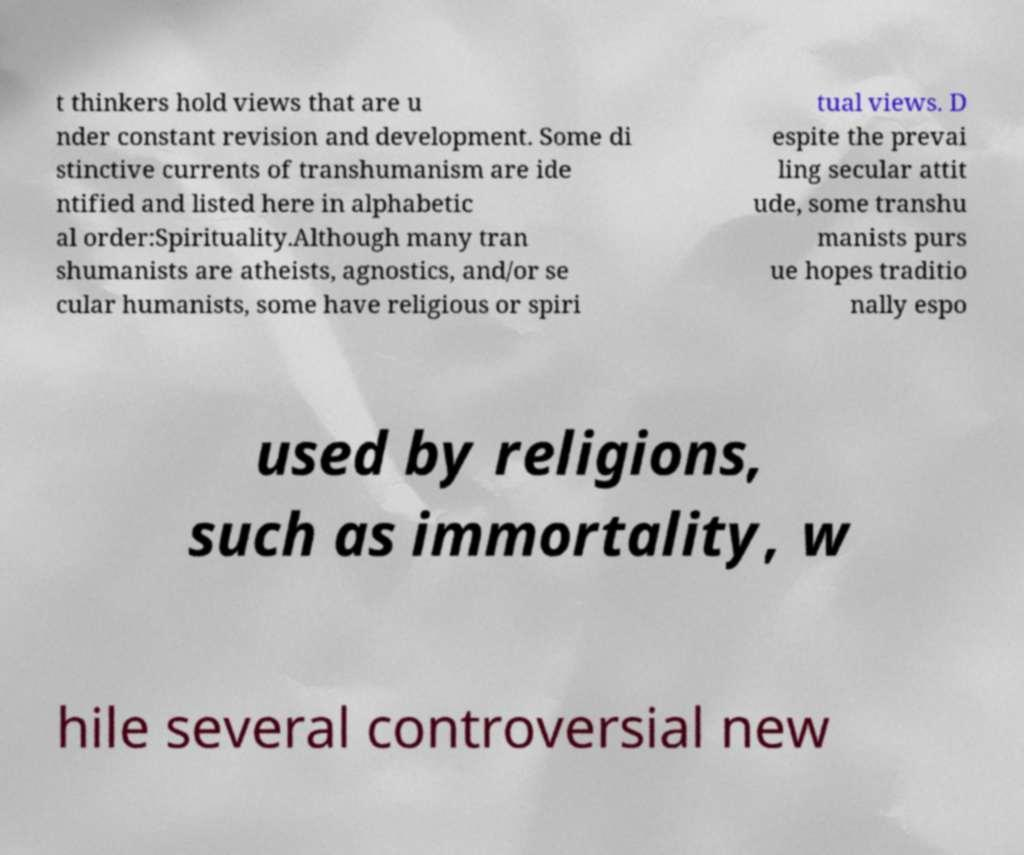Could you extract and type out the text from this image? t thinkers hold views that are u nder constant revision and development. Some di stinctive currents of transhumanism are ide ntified and listed here in alphabetic al order:Spirituality.Although many tran shumanists are atheists, agnostics, and/or se cular humanists, some have religious or spiri tual views. D espite the prevai ling secular attit ude, some transhu manists purs ue hopes traditio nally espo used by religions, such as immortality, w hile several controversial new 